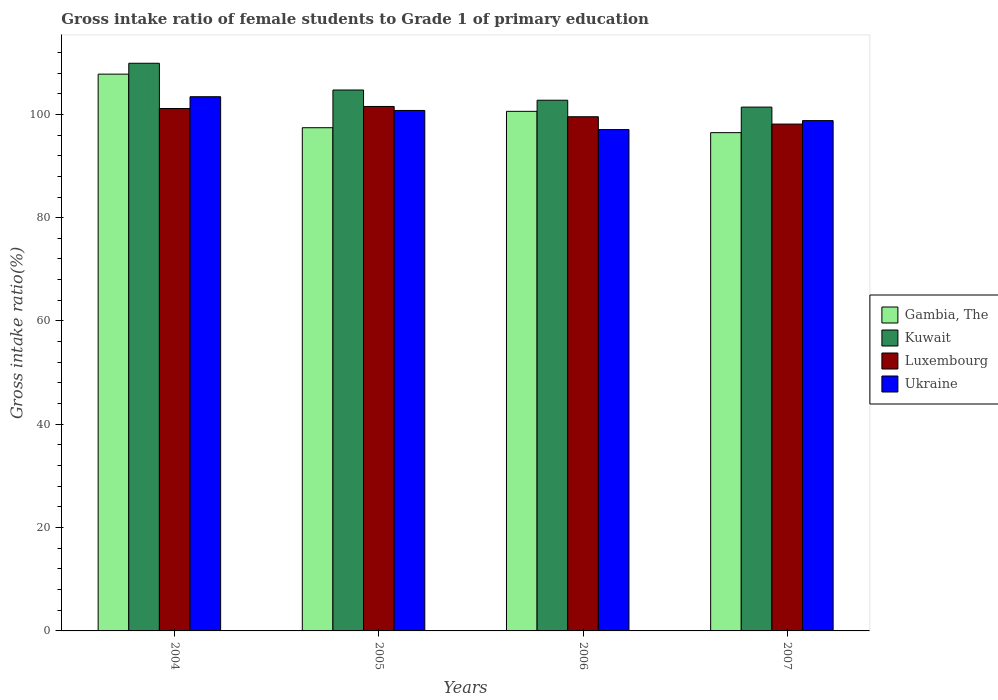Are the number of bars per tick equal to the number of legend labels?
Give a very brief answer. Yes. Are the number of bars on each tick of the X-axis equal?
Keep it short and to the point. Yes. How many bars are there on the 2nd tick from the right?
Your response must be concise. 4. What is the label of the 1st group of bars from the left?
Provide a short and direct response. 2004. What is the gross intake ratio in Kuwait in 2005?
Your response must be concise. 104.72. Across all years, what is the maximum gross intake ratio in Luxembourg?
Ensure brevity in your answer.  101.53. Across all years, what is the minimum gross intake ratio in Ukraine?
Ensure brevity in your answer.  97.06. In which year was the gross intake ratio in Kuwait maximum?
Your answer should be compact. 2004. In which year was the gross intake ratio in Ukraine minimum?
Give a very brief answer. 2006. What is the total gross intake ratio in Gambia, The in the graph?
Your response must be concise. 402.25. What is the difference between the gross intake ratio in Kuwait in 2006 and that in 2007?
Your response must be concise. 1.33. What is the difference between the gross intake ratio in Kuwait in 2005 and the gross intake ratio in Gambia, The in 2006?
Your answer should be compact. 4.13. What is the average gross intake ratio in Luxembourg per year?
Provide a succinct answer. 100.08. In the year 2006, what is the difference between the gross intake ratio in Kuwait and gross intake ratio in Luxembourg?
Your answer should be very brief. 3.2. What is the ratio of the gross intake ratio in Kuwait in 2004 to that in 2006?
Your answer should be compact. 1.07. What is the difference between the highest and the second highest gross intake ratio in Ukraine?
Keep it short and to the point. 2.66. What is the difference between the highest and the lowest gross intake ratio in Kuwait?
Ensure brevity in your answer.  8.49. In how many years, is the gross intake ratio in Gambia, The greater than the average gross intake ratio in Gambia, The taken over all years?
Your response must be concise. 2. Is the sum of the gross intake ratio in Kuwait in 2004 and 2007 greater than the maximum gross intake ratio in Ukraine across all years?
Provide a succinct answer. Yes. What does the 3rd bar from the left in 2005 represents?
Offer a terse response. Luxembourg. What does the 1st bar from the right in 2005 represents?
Make the answer very short. Ukraine. Are all the bars in the graph horizontal?
Your answer should be very brief. No. Are the values on the major ticks of Y-axis written in scientific E-notation?
Give a very brief answer. No. Does the graph contain grids?
Provide a short and direct response. No. Where does the legend appear in the graph?
Your answer should be compact. Center right. How many legend labels are there?
Your answer should be very brief. 4. What is the title of the graph?
Give a very brief answer. Gross intake ratio of female students to Grade 1 of primary education. Does "Upper middle income" appear as one of the legend labels in the graph?
Your answer should be compact. No. What is the label or title of the X-axis?
Ensure brevity in your answer.  Years. What is the label or title of the Y-axis?
Keep it short and to the point. Gross intake ratio(%). What is the Gross intake ratio(%) in Gambia, The in 2004?
Ensure brevity in your answer.  107.79. What is the Gross intake ratio(%) in Kuwait in 2004?
Your answer should be compact. 109.89. What is the Gross intake ratio(%) of Luxembourg in 2004?
Keep it short and to the point. 101.13. What is the Gross intake ratio(%) in Ukraine in 2004?
Your answer should be very brief. 103.42. What is the Gross intake ratio(%) in Gambia, The in 2005?
Give a very brief answer. 97.42. What is the Gross intake ratio(%) of Kuwait in 2005?
Ensure brevity in your answer.  104.72. What is the Gross intake ratio(%) in Luxembourg in 2005?
Offer a very short reply. 101.53. What is the Gross intake ratio(%) of Ukraine in 2005?
Provide a short and direct response. 100.75. What is the Gross intake ratio(%) of Gambia, The in 2006?
Provide a succinct answer. 100.59. What is the Gross intake ratio(%) of Kuwait in 2006?
Offer a very short reply. 102.74. What is the Gross intake ratio(%) of Luxembourg in 2006?
Keep it short and to the point. 99.54. What is the Gross intake ratio(%) in Ukraine in 2006?
Your response must be concise. 97.06. What is the Gross intake ratio(%) in Gambia, The in 2007?
Provide a succinct answer. 96.46. What is the Gross intake ratio(%) in Kuwait in 2007?
Make the answer very short. 101.4. What is the Gross intake ratio(%) of Luxembourg in 2007?
Offer a very short reply. 98.12. What is the Gross intake ratio(%) of Ukraine in 2007?
Offer a very short reply. 98.79. Across all years, what is the maximum Gross intake ratio(%) in Gambia, The?
Your answer should be very brief. 107.79. Across all years, what is the maximum Gross intake ratio(%) of Kuwait?
Ensure brevity in your answer.  109.89. Across all years, what is the maximum Gross intake ratio(%) in Luxembourg?
Offer a very short reply. 101.53. Across all years, what is the maximum Gross intake ratio(%) in Ukraine?
Make the answer very short. 103.42. Across all years, what is the minimum Gross intake ratio(%) in Gambia, The?
Offer a terse response. 96.46. Across all years, what is the minimum Gross intake ratio(%) in Kuwait?
Make the answer very short. 101.4. Across all years, what is the minimum Gross intake ratio(%) in Luxembourg?
Your answer should be compact. 98.12. Across all years, what is the minimum Gross intake ratio(%) of Ukraine?
Offer a very short reply. 97.06. What is the total Gross intake ratio(%) of Gambia, The in the graph?
Your answer should be very brief. 402.25. What is the total Gross intake ratio(%) in Kuwait in the graph?
Your answer should be compact. 418.75. What is the total Gross intake ratio(%) of Luxembourg in the graph?
Your answer should be compact. 400.32. What is the total Gross intake ratio(%) in Ukraine in the graph?
Provide a succinct answer. 400.02. What is the difference between the Gross intake ratio(%) in Gambia, The in 2004 and that in 2005?
Your response must be concise. 10.37. What is the difference between the Gross intake ratio(%) of Kuwait in 2004 and that in 2005?
Your answer should be compact. 5.18. What is the difference between the Gross intake ratio(%) of Luxembourg in 2004 and that in 2005?
Your answer should be very brief. -0.4. What is the difference between the Gross intake ratio(%) in Ukraine in 2004 and that in 2005?
Keep it short and to the point. 2.66. What is the difference between the Gross intake ratio(%) of Gambia, The in 2004 and that in 2006?
Give a very brief answer. 7.2. What is the difference between the Gross intake ratio(%) in Kuwait in 2004 and that in 2006?
Your response must be concise. 7.16. What is the difference between the Gross intake ratio(%) in Luxembourg in 2004 and that in 2006?
Offer a very short reply. 1.6. What is the difference between the Gross intake ratio(%) in Ukraine in 2004 and that in 2006?
Your response must be concise. 6.36. What is the difference between the Gross intake ratio(%) in Gambia, The in 2004 and that in 2007?
Offer a terse response. 11.33. What is the difference between the Gross intake ratio(%) in Kuwait in 2004 and that in 2007?
Provide a succinct answer. 8.49. What is the difference between the Gross intake ratio(%) of Luxembourg in 2004 and that in 2007?
Offer a terse response. 3.01. What is the difference between the Gross intake ratio(%) of Ukraine in 2004 and that in 2007?
Provide a succinct answer. 4.63. What is the difference between the Gross intake ratio(%) in Gambia, The in 2005 and that in 2006?
Your answer should be very brief. -3.17. What is the difference between the Gross intake ratio(%) of Kuwait in 2005 and that in 2006?
Keep it short and to the point. 1.98. What is the difference between the Gross intake ratio(%) of Luxembourg in 2005 and that in 2006?
Give a very brief answer. 1.99. What is the difference between the Gross intake ratio(%) in Ukraine in 2005 and that in 2006?
Offer a very short reply. 3.7. What is the difference between the Gross intake ratio(%) in Gambia, The in 2005 and that in 2007?
Keep it short and to the point. 0.96. What is the difference between the Gross intake ratio(%) in Kuwait in 2005 and that in 2007?
Your answer should be compact. 3.31. What is the difference between the Gross intake ratio(%) of Luxembourg in 2005 and that in 2007?
Your response must be concise. 3.41. What is the difference between the Gross intake ratio(%) of Ukraine in 2005 and that in 2007?
Offer a very short reply. 1.96. What is the difference between the Gross intake ratio(%) in Gambia, The in 2006 and that in 2007?
Give a very brief answer. 4.13. What is the difference between the Gross intake ratio(%) in Kuwait in 2006 and that in 2007?
Make the answer very short. 1.33. What is the difference between the Gross intake ratio(%) of Luxembourg in 2006 and that in 2007?
Your response must be concise. 1.42. What is the difference between the Gross intake ratio(%) in Ukraine in 2006 and that in 2007?
Offer a terse response. -1.74. What is the difference between the Gross intake ratio(%) of Gambia, The in 2004 and the Gross intake ratio(%) of Kuwait in 2005?
Your response must be concise. 3.07. What is the difference between the Gross intake ratio(%) in Gambia, The in 2004 and the Gross intake ratio(%) in Luxembourg in 2005?
Your answer should be compact. 6.26. What is the difference between the Gross intake ratio(%) in Gambia, The in 2004 and the Gross intake ratio(%) in Ukraine in 2005?
Your answer should be compact. 7.03. What is the difference between the Gross intake ratio(%) in Kuwait in 2004 and the Gross intake ratio(%) in Luxembourg in 2005?
Make the answer very short. 8.36. What is the difference between the Gross intake ratio(%) in Kuwait in 2004 and the Gross intake ratio(%) in Ukraine in 2005?
Ensure brevity in your answer.  9.14. What is the difference between the Gross intake ratio(%) of Luxembourg in 2004 and the Gross intake ratio(%) of Ukraine in 2005?
Keep it short and to the point. 0.38. What is the difference between the Gross intake ratio(%) of Gambia, The in 2004 and the Gross intake ratio(%) of Kuwait in 2006?
Your response must be concise. 5.05. What is the difference between the Gross intake ratio(%) in Gambia, The in 2004 and the Gross intake ratio(%) in Luxembourg in 2006?
Provide a short and direct response. 8.25. What is the difference between the Gross intake ratio(%) of Gambia, The in 2004 and the Gross intake ratio(%) of Ukraine in 2006?
Give a very brief answer. 10.73. What is the difference between the Gross intake ratio(%) in Kuwait in 2004 and the Gross intake ratio(%) in Luxembourg in 2006?
Offer a terse response. 10.36. What is the difference between the Gross intake ratio(%) of Kuwait in 2004 and the Gross intake ratio(%) of Ukraine in 2006?
Your response must be concise. 12.84. What is the difference between the Gross intake ratio(%) of Luxembourg in 2004 and the Gross intake ratio(%) of Ukraine in 2006?
Your answer should be very brief. 4.08. What is the difference between the Gross intake ratio(%) in Gambia, The in 2004 and the Gross intake ratio(%) in Kuwait in 2007?
Your answer should be compact. 6.38. What is the difference between the Gross intake ratio(%) in Gambia, The in 2004 and the Gross intake ratio(%) in Luxembourg in 2007?
Your answer should be very brief. 9.67. What is the difference between the Gross intake ratio(%) of Gambia, The in 2004 and the Gross intake ratio(%) of Ukraine in 2007?
Your answer should be very brief. 9. What is the difference between the Gross intake ratio(%) of Kuwait in 2004 and the Gross intake ratio(%) of Luxembourg in 2007?
Your response must be concise. 11.77. What is the difference between the Gross intake ratio(%) of Luxembourg in 2004 and the Gross intake ratio(%) of Ukraine in 2007?
Provide a succinct answer. 2.34. What is the difference between the Gross intake ratio(%) in Gambia, The in 2005 and the Gross intake ratio(%) in Kuwait in 2006?
Keep it short and to the point. -5.32. What is the difference between the Gross intake ratio(%) in Gambia, The in 2005 and the Gross intake ratio(%) in Luxembourg in 2006?
Your answer should be compact. -2.12. What is the difference between the Gross intake ratio(%) in Gambia, The in 2005 and the Gross intake ratio(%) in Ukraine in 2006?
Keep it short and to the point. 0.36. What is the difference between the Gross intake ratio(%) in Kuwait in 2005 and the Gross intake ratio(%) in Luxembourg in 2006?
Offer a terse response. 5.18. What is the difference between the Gross intake ratio(%) in Kuwait in 2005 and the Gross intake ratio(%) in Ukraine in 2006?
Ensure brevity in your answer.  7.66. What is the difference between the Gross intake ratio(%) of Luxembourg in 2005 and the Gross intake ratio(%) of Ukraine in 2006?
Offer a very short reply. 4.47. What is the difference between the Gross intake ratio(%) of Gambia, The in 2005 and the Gross intake ratio(%) of Kuwait in 2007?
Make the answer very short. -3.99. What is the difference between the Gross intake ratio(%) of Gambia, The in 2005 and the Gross intake ratio(%) of Luxembourg in 2007?
Offer a very short reply. -0.7. What is the difference between the Gross intake ratio(%) in Gambia, The in 2005 and the Gross intake ratio(%) in Ukraine in 2007?
Your answer should be very brief. -1.38. What is the difference between the Gross intake ratio(%) in Kuwait in 2005 and the Gross intake ratio(%) in Luxembourg in 2007?
Give a very brief answer. 6.59. What is the difference between the Gross intake ratio(%) in Kuwait in 2005 and the Gross intake ratio(%) in Ukraine in 2007?
Offer a terse response. 5.92. What is the difference between the Gross intake ratio(%) of Luxembourg in 2005 and the Gross intake ratio(%) of Ukraine in 2007?
Your answer should be compact. 2.74. What is the difference between the Gross intake ratio(%) of Gambia, The in 2006 and the Gross intake ratio(%) of Kuwait in 2007?
Offer a very short reply. -0.82. What is the difference between the Gross intake ratio(%) of Gambia, The in 2006 and the Gross intake ratio(%) of Luxembourg in 2007?
Your answer should be very brief. 2.46. What is the difference between the Gross intake ratio(%) in Gambia, The in 2006 and the Gross intake ratio(%) in Ukraine in 2007?
Offer a terse response. 1.79. What is the difference between the Gross intake ratio(%) in Kuwait in 2006 and the Gross intake ratio(%) in Luxembourg in 2007?
Make the answer very short. 4.62. What is the difference between the Gross intake ratio(%) in Kuwait in 2006 and the Gross intake ratio(%) in Ukraine in 2007?
Make the answer very short. 3.94. What is the difference between the Gross intake ratio(%) in Luxembourg in 2006 and the Gross intake ratio(%) in Ukraine in 2007?
Your response must be concise. 0.74. What is the average Gross intake ratio(%) in Gambia, The per year?
Your answer should be very brief. 100.56. What is the average Gross intake ratio(%) of Kuwait per year?
Offer a terse response. 104.69. What is the average Gross intake ratio(%) of Luxembourg per year?
Your answer should be compact. 100.08. What is the average Gross intake ratio(%) of Ukraine per year?
Ensure brevity in your answer.  100.01. In the year 2004, what is the difference between the Gross intake ratio(%) in Gambia, The and Gross intake ratio(%) in Kuwait?
Keep it short and to the point. -2.1. In the year 2004, what is the difference between the Gross intake ratio(%) in Gambia, The and Gross intake ratio(%) in Luxembourg?
Your answer should be compact. 6.65. In the year 2004, what is the difference between the Gross intake ratio(%) of Gambia, The and Gross intake ratio(%) of Ukraine?
Your response must be concise. 4.37. In the year 2004, what is the difference between the Gross intake ratio(%) of Kuwait and Gross intake ratio(%) of Luxembourg?
Your response must be concise. 8.76. In the year 2004, what is the difference between the Gross intake ratio(%) of Kuwait and Gross intake ratio(%) of Ukraine?
Provide a short and direct response. 6.47. In the year 2004, what is the difference between the Gross intake ratio(%) in Luxembourg and Gross intake ratio(%) in Ukraine?
Provide a succinct answer. -2.28. In the year 2005, what is the difference between the Gross intake ratio(%) of Gambia, The and Gross intake ratio(%) of Kuwait?
Ensure brevity in your answer.  -7.3. In the year 2005, what is the difference between the Gross intake ratio(%) of Gambia, The and Gross intake ratio(%) of Luxembourg?
Provide a short and direct response. -4.11. In the year 2005, what is the difference between the Gross intake ratio(%) in Gambia, The and Gross intake ratio(%) in Ukraine?
Your answer should be very brief. -3.34. In the year 2005, what is the difference between the Gross intake ratio(%) of Kuwait and Gross intake ratio(%) of Luxembourg?
Offer a terse response. 3.19. In the year 2005, what is the difference between the Gross intake ratio(%) of Kuwait and Gross intake ratio(%) of Ukraine?
Make the answer very short. 3.96. In the year 2005, what is the difference between the Gross intake ratio(%) of Luxembourg and Gross intake ratio(%) of Ukraine?
Ensure brevity in your answer.  0.77. In the year 2006, what is the difference between the Gross intake ratio(%) in Gambia, The and Gross intake ratio(%) in Kuwait?
Provide a succinct answer. -2.15. In the year 2006, what is the difference between the Gross intake ratio(%) in Gambia, The and Gross intake ratio(%) in Luxembourg?
Provide a short and direct response. 1.05. In the year 2006, what is the difference between the Gross intake ratio(%) in Gambia, The and Gross intake ratio(%) in Ukraine?
Your answer should be compact. 3.53. In the year 2006, what is the difference between the Gross intake ratio(%) in Kuwait and Gross intake ratio(%) in Luxembourg?
Keep it short and to the point. 3.2. In the year 2006, what is the difference between the Gross intake ratio(%) in Kuwait and Gross intake ratio(%) in Ukraine?
Offer a terse response. 5.68. In the year 2006, what is the difference between the Gross intake ratio(%) in Luxembourg and Gross intake ratio(%) in Ukraine?
Your answer should be very brief. 2.48. In the year 2007, what is the difference between the Gross intake ratio(%) of Gambia, The and Gross intake ratio(%) of Kuwait?
Your answer should be compact. -4.95. In the year 2007, what is the difference between the Gross intake ratio(%) of Gambia, The and Gross intake ratio(%) of Luxembourg?
Provide a short and direct response. -1.66. In the year 2007, what is the difference between the Gross intake ratio(%) of Gambia, The and Gross intake ratio(%) of Ukraine?
Your answer should be very brief. -2.33. In the year 2007, what is the difference between the Gross intake ratio(%) in Kuwait and Gross intake ratio(%) in Luxembourg?
Keep it short and to the point. 3.28. In the year 2007, what is the difference between the Gross intake ratio(%) in Kuwait and Gross intake ratio(%) in Ukraine?
Your answer should be very brief. 2.61. In the year 2007, what is the difference between the Gross intake ratio(%) of Luxembourg and Gross intake ratio(%) of Ukraine?
Your response must be concise. -0.67. What is the ratio of the Gross intake ratio(%) of Gambia, The in 2004 to that in 2005?
Ensure brevity in your answer.  1.11. What is the ratio of the Gross intake ratio(%) in Kuwait in 2004 to that in 2005?
Provide a succinct answer. 1.05. What is the ratio of the Gross intake ratio(%) in Ukraine in 2004 to that in 2005?
Keep it short and to the point. 1.03. What is the ratio of the Gross intake ratio(%) of Gambia, The in 2004 to that in 2006?
Your answer should be compact. 1.07. What is the ratio of the Gross intake ratio(%) in Kuwait in 2004 to that in 2006?
Provide a succinct answer. 1.07. What is the ratio of the Gross intake ratio(%) of Ukraine in 2004 to that in 2006?
Provide a short and direct response. 1.07. What is the ratio of the Gross intake ratio(%) in Gambia, The in 2004 to that in 2007?
Your answer should be very brief. 1.12. What is the ratio of the Gross intake ratio(%) in Kuwait in 2004 to that in 2007?
Make the answer very short. 1.08. What is the ratio of the Gross intake ratio(%) of Luxembourg in 2004 to that in 2007?
Ensure brevity in your answer.  1.03. What is the ratio of the Gross intake ratio(%) of Ukraine in 2004 to that in 2007?
Offer a terse response. 1.05. What is the ratio of the Gross intake ratio(%) of Gambia, The in 2005 to that in 2006?
Ensure brevity in your answer.  0.97. What is the ratio of the Gross intake ratio(%) of Kuwait in 2005 to that in 2006?
Your answer should be compact. 1.02. What is the ratio of the Gross intake ratio(%) of Luxembourg in 2005 to that in 2006?
Your answer should be compact. 1.02. What is the ratio of the Gross intake ratio(%) of Ukraine in 2005 to that in 2006?
Your answer should be very brief. 1.04. What is the ratio of the Gross intake ratio(%) of Gambia, The in 2005 to that in 2007?
Provide a short and direct response. 1.01. What is the ratio of the Gross intake ratio(%) of Kuwait in 2005 to that in 2007?
Make the answer very short. 1.03. What is the ratio of the Gross intake ratio(%) of Luxembourg in 2005 to that in 2007?
Offer a very short reply. 1.03. What is the ratio of the Gross intake ratio(%) in Ukraine in 2005 to that in 2007?
Offer a terse response. 1.02. What is the ratio of the Gross intake ratio(%) in Gambia, The in 2006 to that in 2007?
Make the answer very short. 1.04. What is the ratio of the Gross intake ratio(%) of Kuwait in 2006 to that in 2007?
Keep it short and to the point. 1.01. What is the ratio of the Gross intake ratio(%) of Luxembourg in 2006 to that in 2007?
Provide a succinct answer. 1.01. What is the ratio of the Gross intake ratio(%) of Ukraine in 2006 to that in 2007?
Offer a terse response. 0.98. What is the difference between the highest and the second highest Gross intake ratio(%) of Gambia, The?
Offer a very short reply. 7.2. What is the difference between the highest and the second highest Gross intake ratio(%) in Kuwait?
Offer a very short reply. 5.18. What is the difference between the highest and the second highest Gross intake ratio(%) of Luxembourg?
Ensure brevity in your answer.  0.4. What is the difference between the highest and the second highest Gross intake ratio(%) in Ukraine?
Make the answer very short. 2.66. What is the difference between the highest and the lowest Gross intake ratio(%) of Gambia, The?
Provide a short and direct response. 11.33. What is the difference between the highest and the lowest Gross intake ratio(%) of Kuwait?
Your response must be concise. 8.49. What is the difference between the highest and the lowest Gross intake ratio(%) in Luxembourg?
Your answer should be very brief. 3.41. What is the difference between the highest and the lowest Gross intake ratio(%) in Ukraine?
Provide a short and direct response. 6.36. 